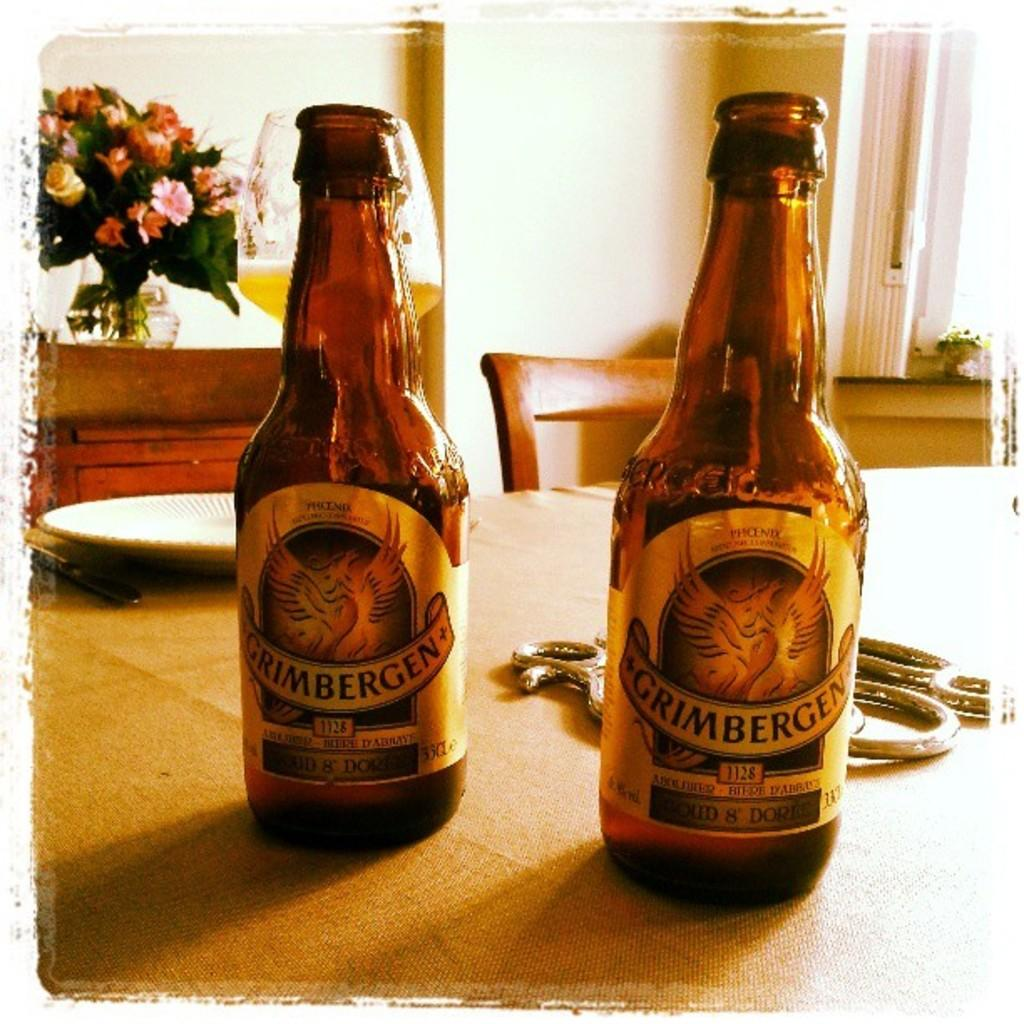Provide a one-sentence caption for the provided image. Two bottles of Grimbergen siting on a table. 